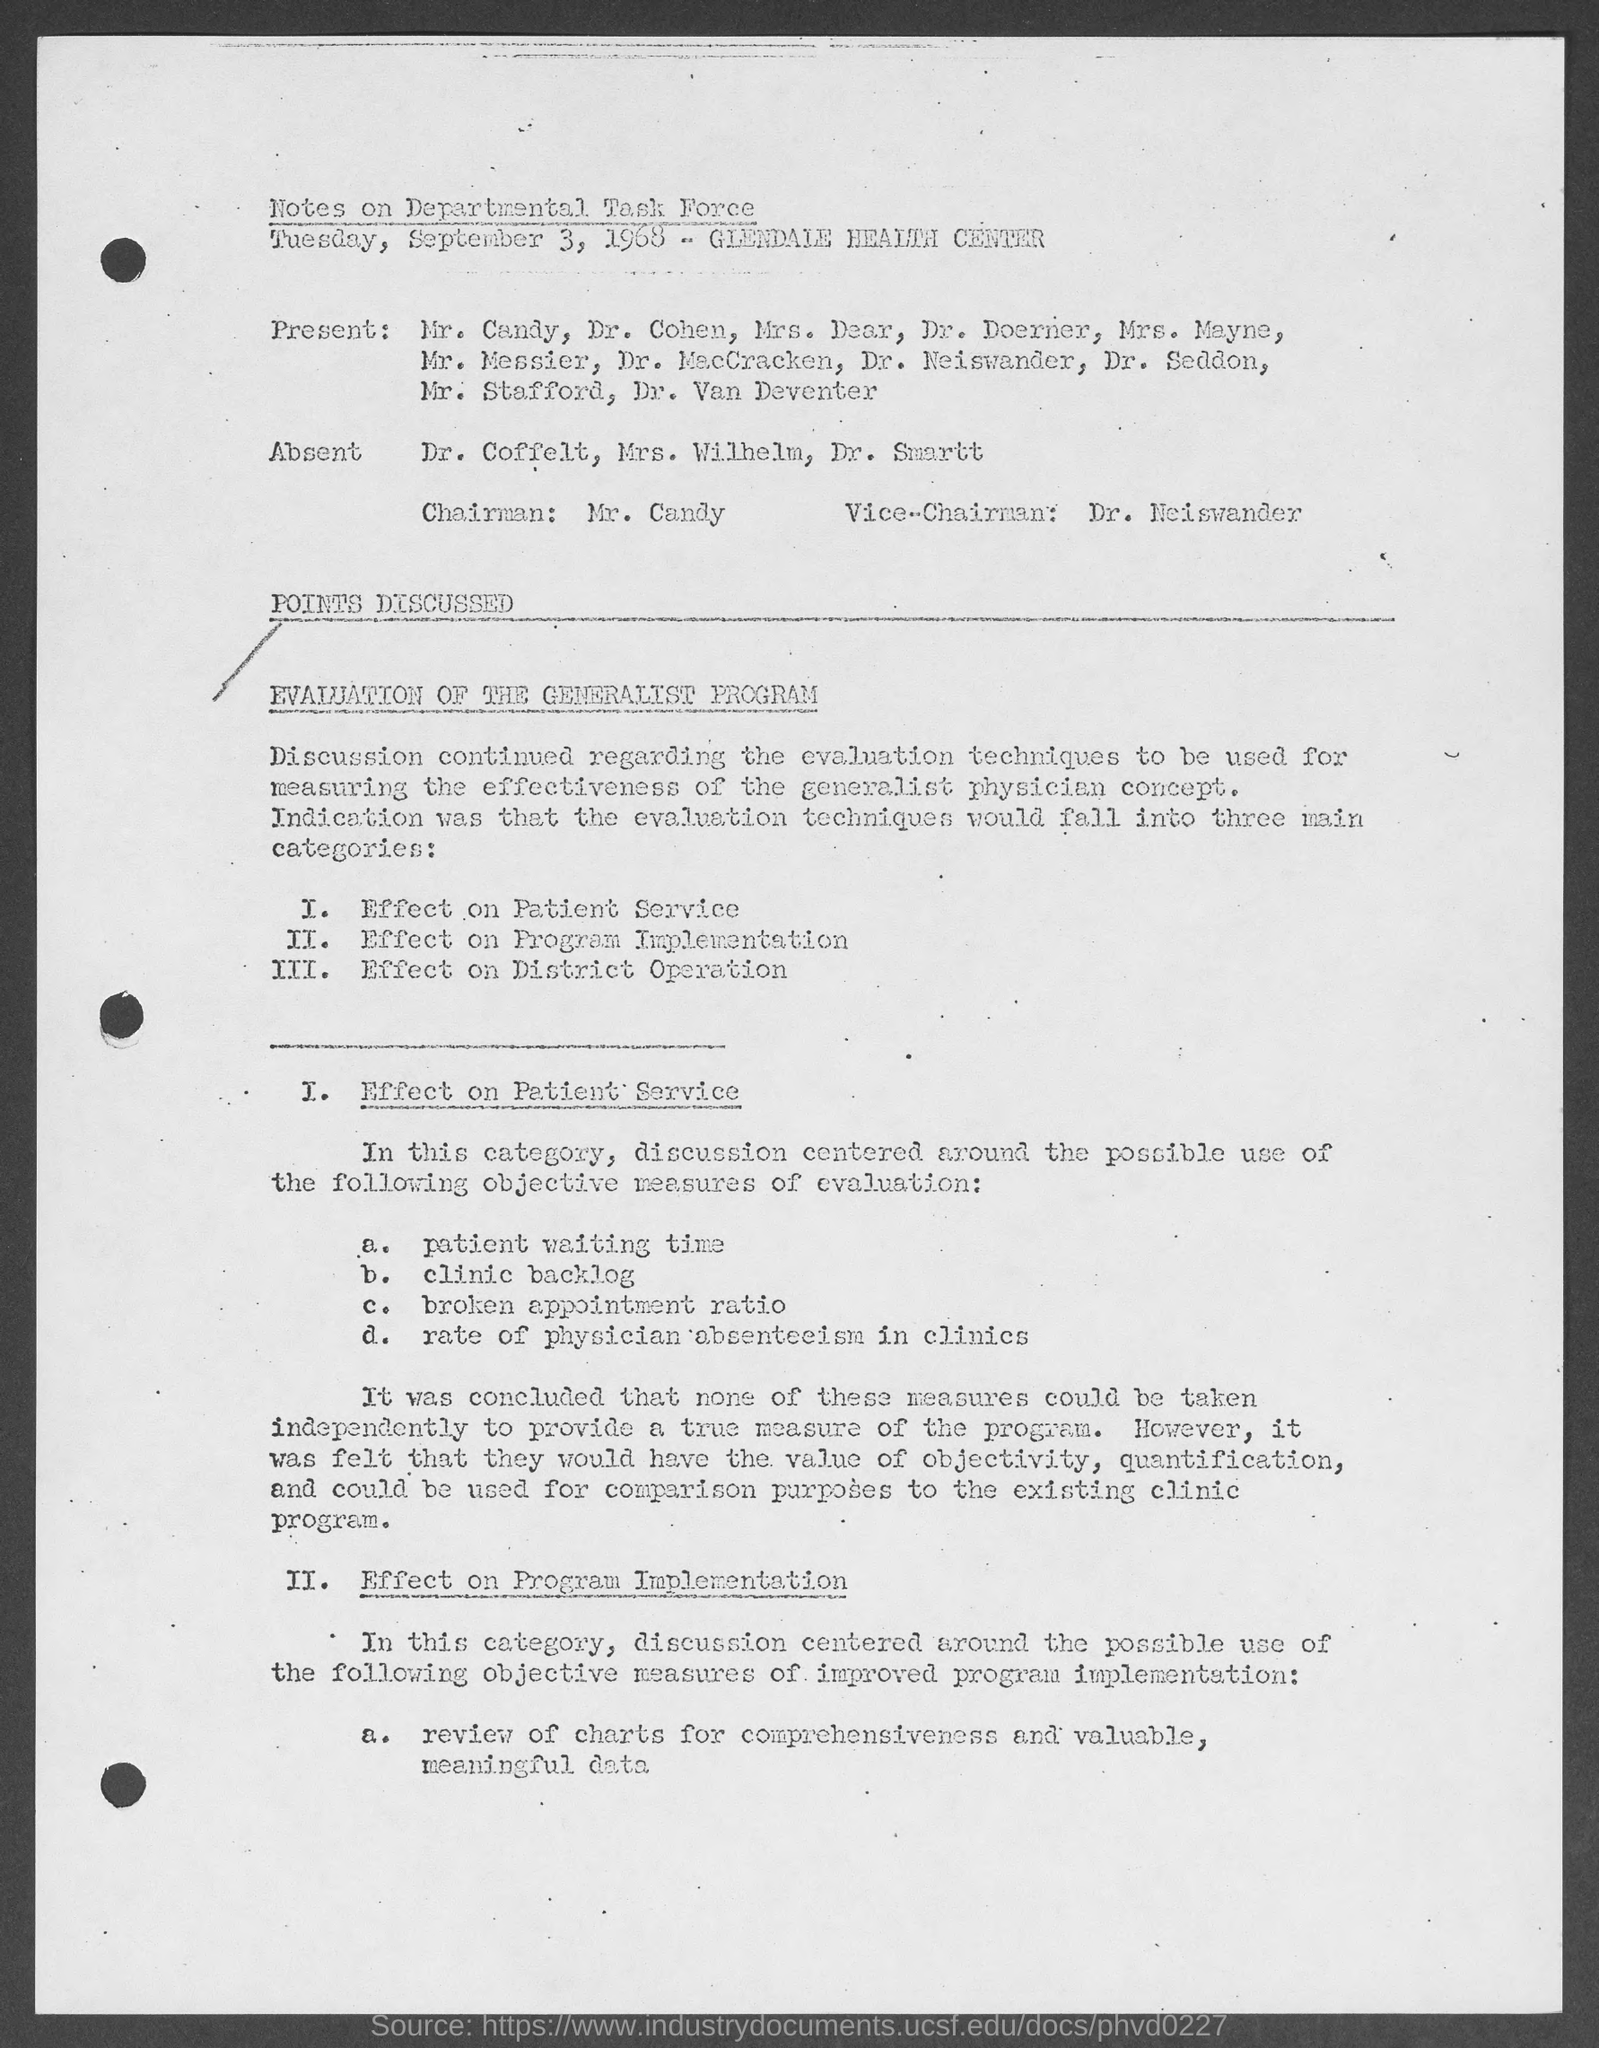Who is the Chairman mentioned in the document? The Chairman mentioned in the document is Mr. Candy. He was present at the Departmental Task Force meeting on September 3, 1968, at the Glendale Health Center, where they discussed the evaluation of the Generalist Program focusing on its effectiveness, program implementation, and its impact on district operation. 